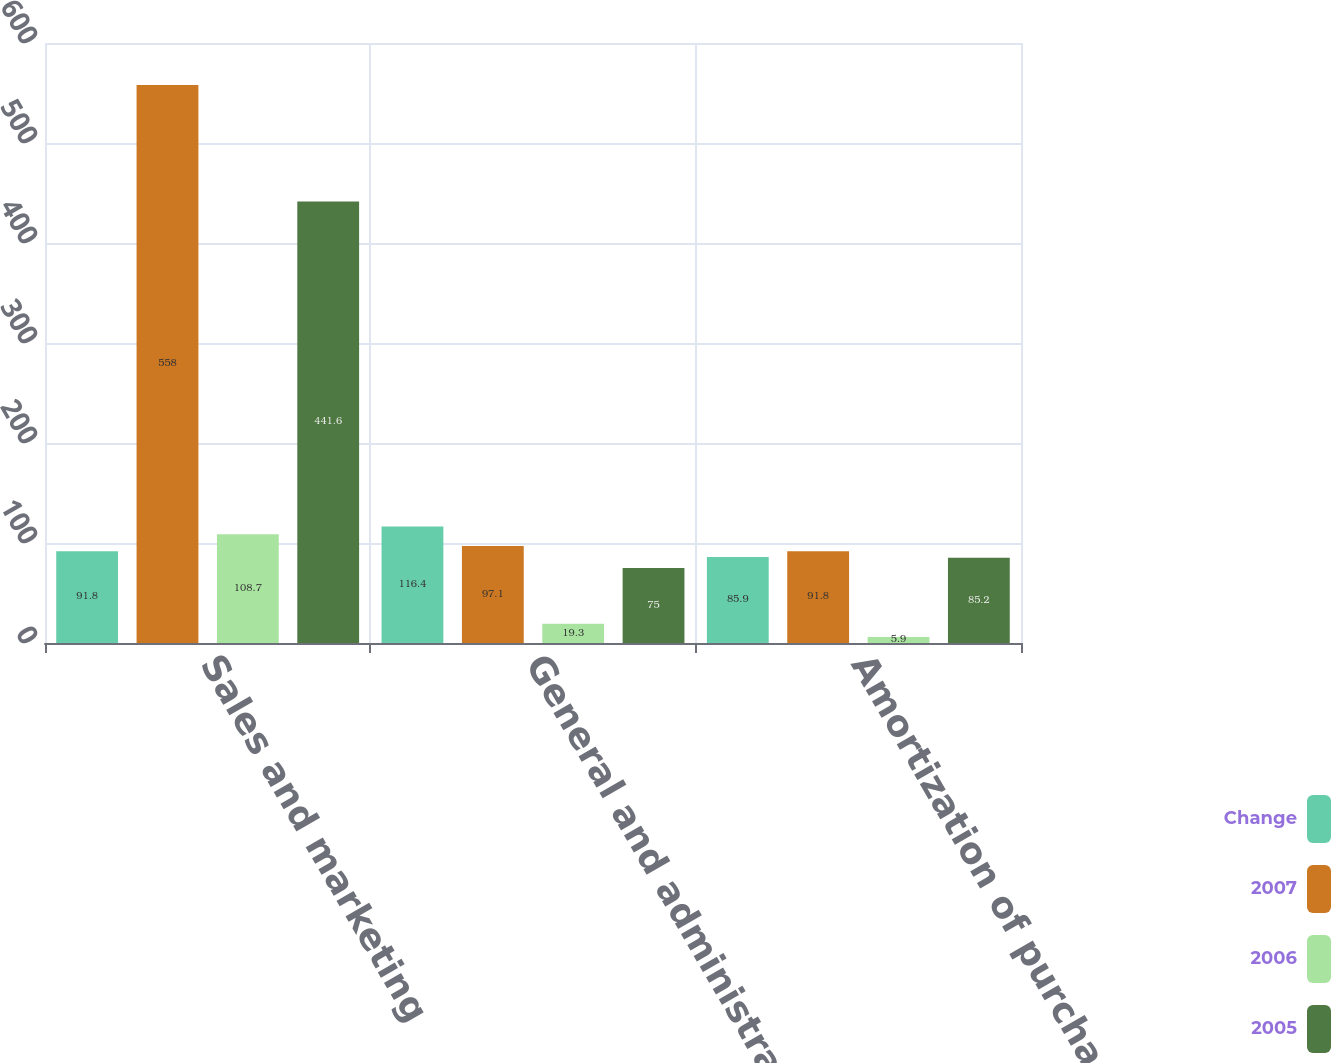Convert chart to OTSL. <chart><loc_0><loc_0><loc_500><loc_500><stacked_bar_chart><ecel><fcel>Sales and marketing<fcel>General and administrative<fcel>Amortization of purchased<nl><fcel>Change<fcel>91.8<fcel>116.4<fcel>85.9<nl><fcel>2007<fcel>558<fcel>97.1<fcel>91.8<nl><fcel>2006<fcel>108.7<fcel>19.3<fcel>5.9<nl><fcel>2005<fcel>441.6<fcel>75<fcel>85.2<nl></chart> 